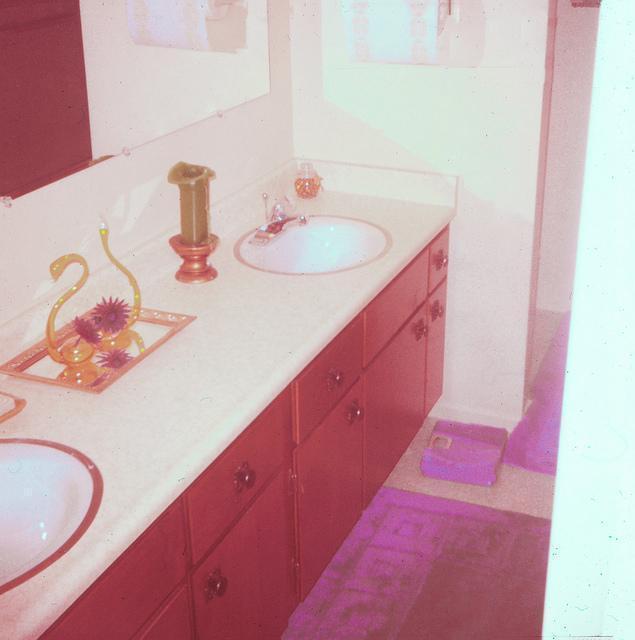What item on the counter has melted?
Answer the question by selecting the correct answer among the 4 following choices and explain your choice with a short sentence. The answer should be formatted with the following format: `Answer: choice
Rationale: rationale.`
Options: Flower, candle, tray, soap. Answer: candle.
Rationale: It is made of wax and has a wick that gets lit 